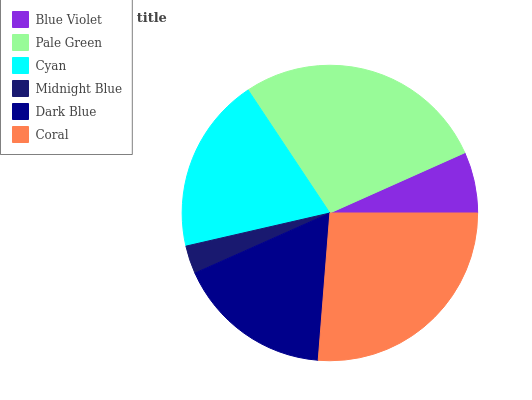Is Midnight Blue the minimum?
Answer yes or no. Yes. Is Pale Green the maximum?
Answer yes or no. Yes. Is Cyan the minimum?
Answer yes or no. No. Is Cyan the maximum?
Answer yes or no. No. Is Pale Green greater than Cyan?
Answer yes or no. Yes. Is Cyan less than Pale Green?
Answer yes or no. Yes. Is Cyan greater than Pale Green?
Answer yes or no. No. Is Pale Green less than Cyan?
Answer yes or no. No. Is Cyan the high median?
Answer yes or no. Yes. Is Dark Blue the low median?
Answer yes or no. Yes. Is Blue Violet the high median?
Answer yes or no. No. Is Pale Green the low median?
Answer yes or no. No. 